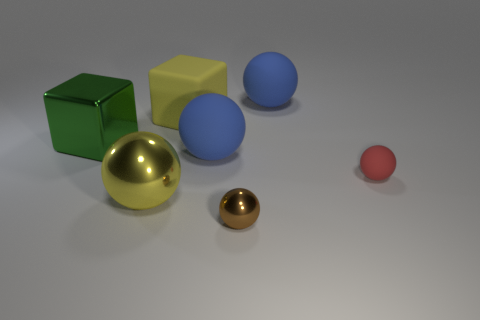Subtract all blue rubber spheres. How many spheres are left? 3 Subtract all yellow balls. How many balls are left? 4 Subtract all yellow spheres. Subtract all red cylinders. How many spheres are left? 4 Add 1 metallic spheres. How many objects exist? 8 Subtract all spheres. How many objects are left? 2 Subtract 0 gray cylinders. How many objects are left? 7 Subtract all blue matte cylinders. Subtract all big green things. How many objects are left? 6 Add 4 green metal objects. How many green metal objects are left? 5 Add 3 big shiny objects. How many big shiny objects exist? 5 